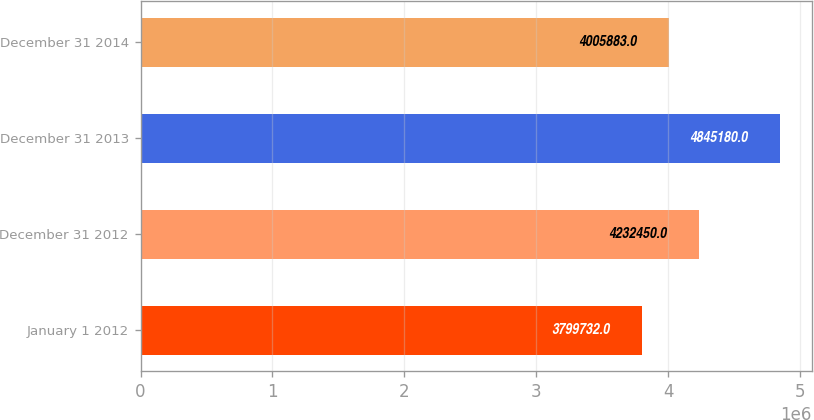<chart> <loc_0><loc_0><loc_500><loc_500><bar_chart><fcel>January 1 2012<fcel>December 31 2012<fcel>December 31 2013<fcel>December 31 2014<nl><fcel>3.79973e+06<fcel>4.23245e+06<fcel>4.84518e+06<fcel>4.00588e+06<nl></chart> 